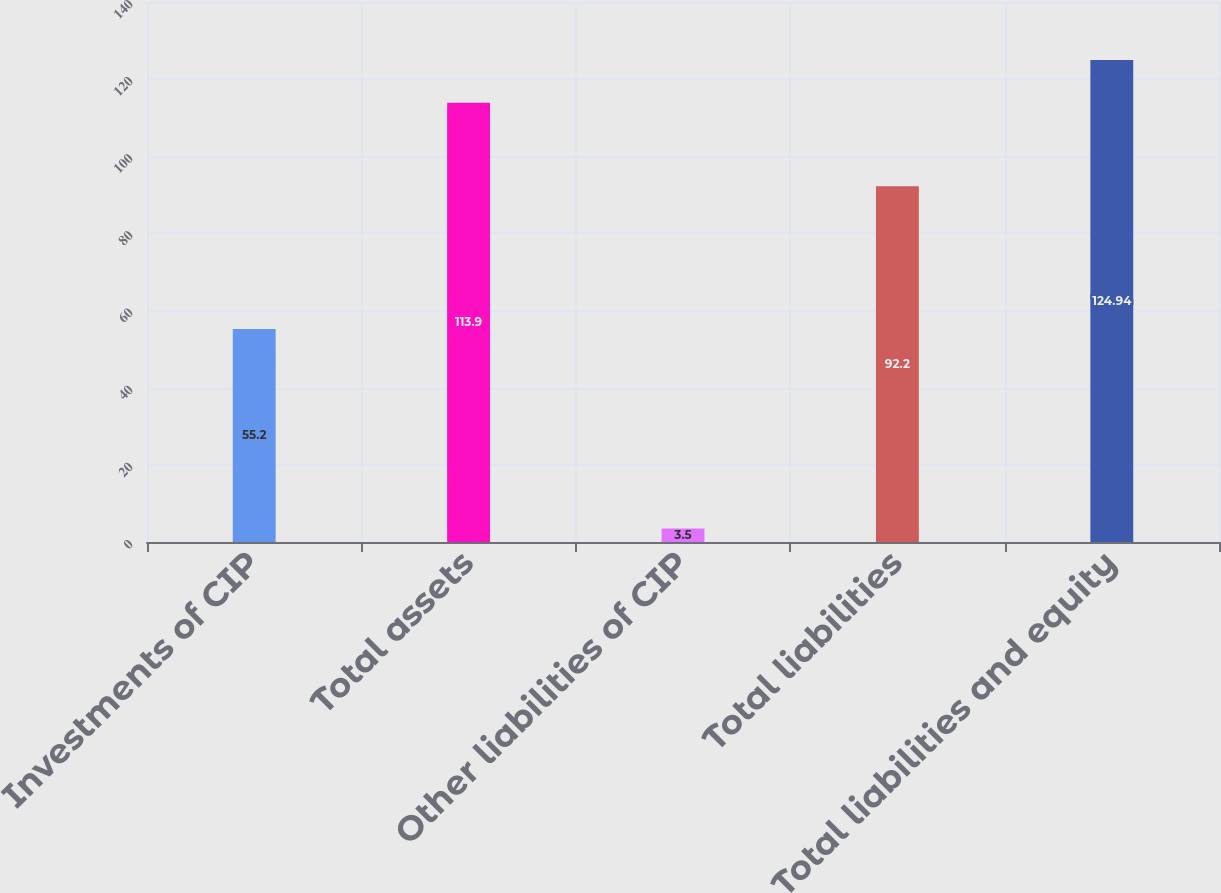<chart> <loc_0><loc_0><loc_500><loc_500><bar_chart><fcel>Investments of CIP<fcel>Total assets<fcel>Other liabilities of CIP<fcel>Total liabilities<fcel>Total liabilities and equity<nl><fcel>55.2<fcel>113.9<fcel>3.5<fcel>92.2<fcel>124.94<nl></chart> 